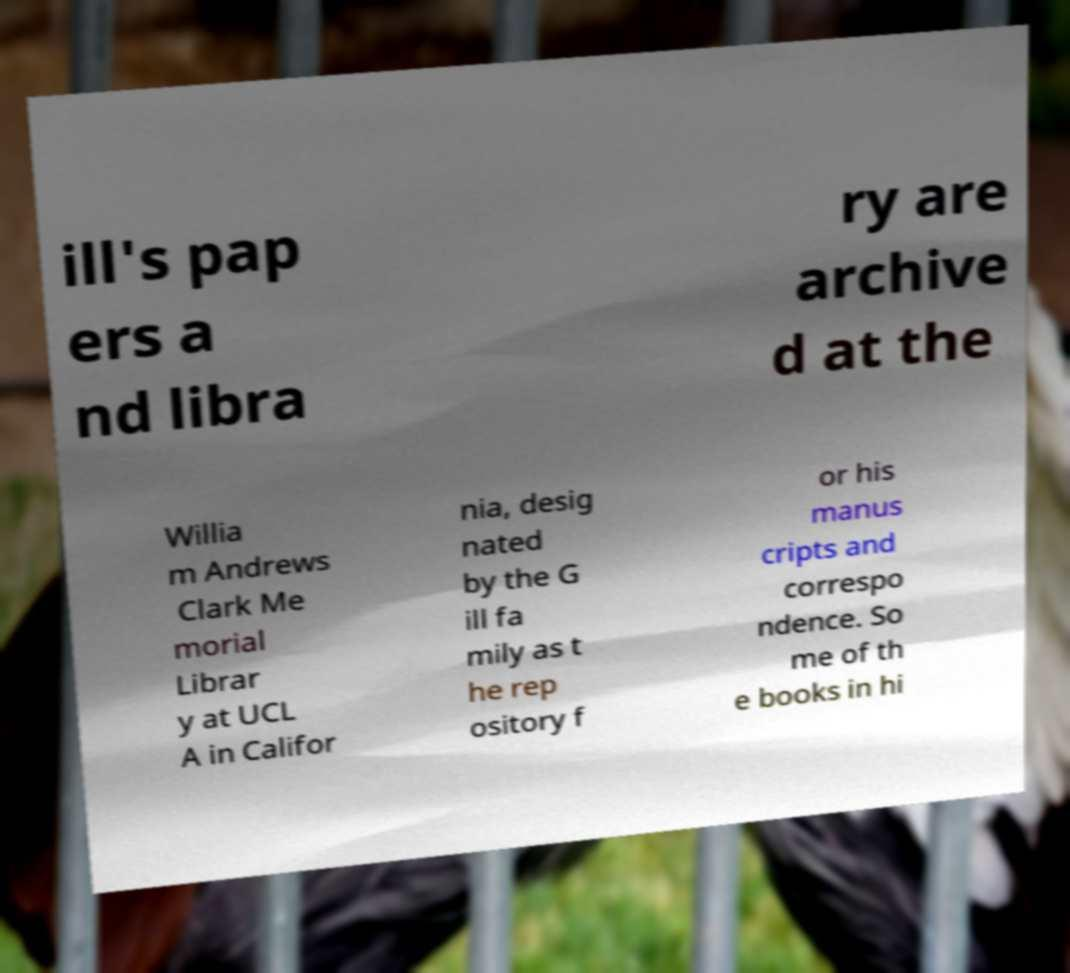There's text embedded in this image that I need extracted. Can you transcribe it verbatim? ill's pap ers a nd libra ry are archive d at the Willia m Andrews Clark Me morial Librar y at UCL A in Califor nia, desig nated by the G ill fa mily as t he rep ository f or his manus cripts and correspo ndence. So me of th e books in hi 